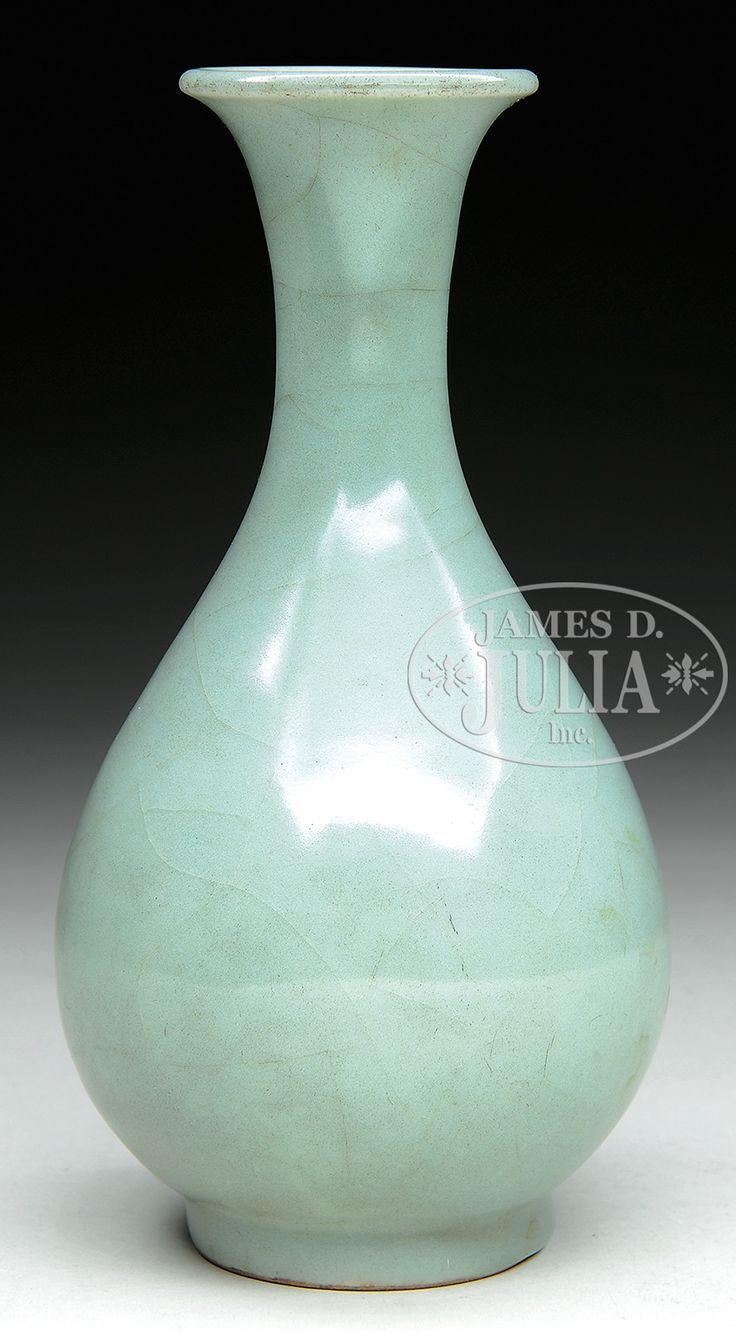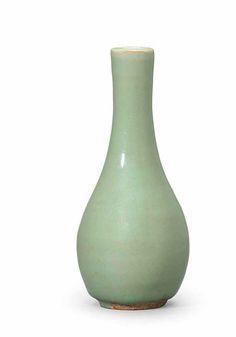The first image is the image on the left, the second image is the image on the right. Assess this claim about the two images: "One of the vases has slender handles on each side, a dimensional ribbed element, and a fluted top.". Correct or not? Answer yes or no. No. The first image is the image on the left, the second image is the image on the right. Considering the images on both sides, is "An image contains a green vase that has two handles around its neck." valid? Answer yes or no. No. 